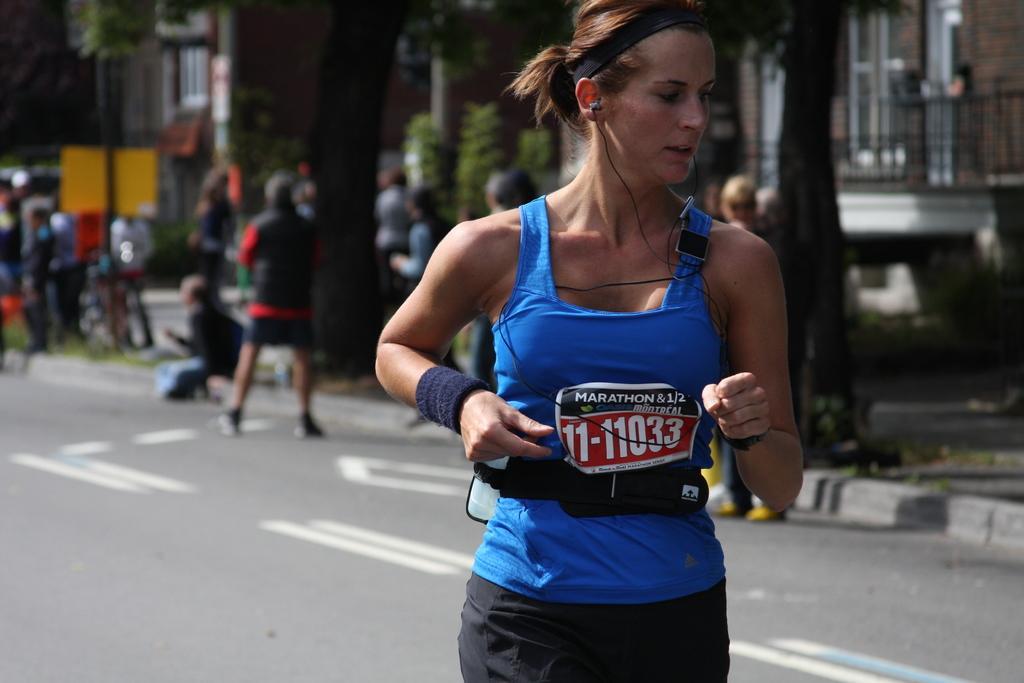Can you describe this image briefly? In the image there is a lady with dress. Behind her there is a blur image. There is a road and there are few people. And also there are trees and buildings with walls. 